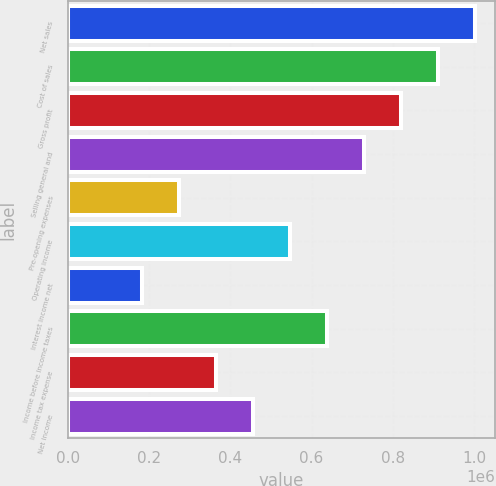Convert chart to OTSL. <chart><loc_0><loc_0><loc_500><loc_500><bar_chart><fcel>Net sales<fcel>Cost of sales<fcel>Gross profit<fcel>Selling general and<fcel>Pre-opening expenses<fcel>Operating income<fcel>Interest income net<fcel>Income before income taxes<fcel>Income tax expense<fcel>Net income<nl><fcel>1.00177e+06<fcel>910700<fcel>819630<fcel>728560<fcel>273211<fcel>546420<fcel>182141<fcel>637490<fcel>364281<fcel>455351<nl></chart> 